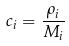<formula> <loc_0><loc_0><loc_500><loc_500>c _ { i } = \frac { \rho _ { i } } { M _ { i } }</formula> 